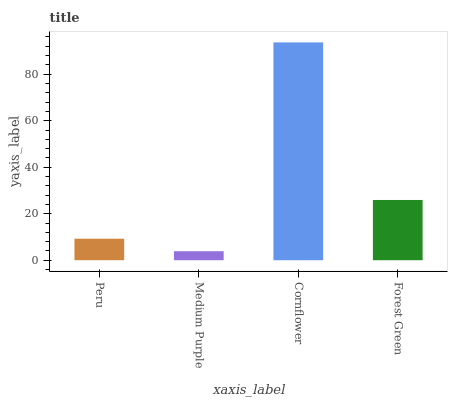Is Medium Purple the minimum?
Answer yes or no. Yes. Is Cornflower the maximum?
Answer yes or no. Yes. Is Cornflower the minimum?
Answer yes or no. No. Is Medium Purple the maximum?
Answer yes or no. No. Is Cornflower greater than Medium Purple?
Answer yes or no. Yes. Is Medium Purple less than Cornflower?
Answer yes or no. Yes. Is Medium Purple greater than Cornflower?
Answer yes or no. No. Is Cornflower less than Medium Purple?
Answer yes or no. No. Is Forest Green the high median?
Answer yes or no. Yes. Is Peru the low median?
Answer yes or no. Yes. Is Medium Purple the high median?
Answer yes or no. No. Is Medium Purple the low median?
Answer yes or no. No. 